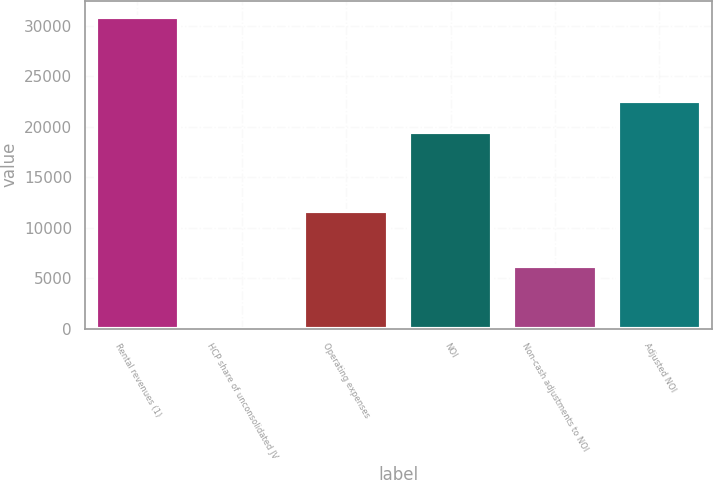<chart> <loc_0><loc_0><loc_500><loc_500><bar_chart><fcel>Rental revenues (1)<fcel>HCP share of unconsolidated JV<fcel>Operating expenses<fcel>NOI<fcel>Non-cash adjustments to NOI<fcel>Adjusted NOI<nl><fcel>30929<fcel>17<fcel>11633<fcel>19439<fcel>6199.4<fcel>22530.2<nl></chart> 